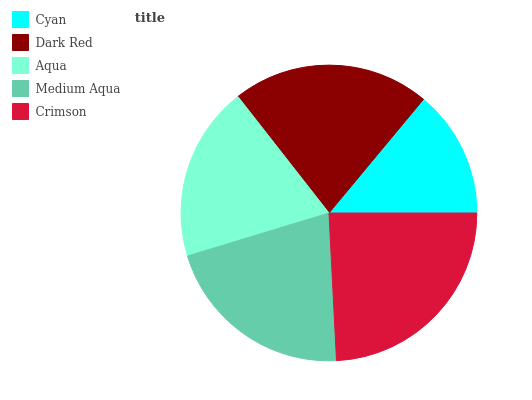Is Cyan the minimum?
Answer yes or no. Yes. Is Crimson the maximum?
Answer yes or no. Yes. Is Dark Red the minimum?
Answer yes or no. No. Is Dark Red the maximum?
Answer yes or no. No. Is Dark Red greater than Cyan?
Answer yes or no. Yes. Is Cyan less than Dark Red?
Answer yes or no. Yes. Is Cyan greater than Dark Red?
Answer yes or no. No. Is Dark Red less than Cyan?
Answer yes or no. No. Is Medium Aqua the high median?
Answer yes or no. Yes. Is Medium Aqua the low median?
Answer yes or no. Yes. Is Dark Red the high median?
Answer yes or no. No. Is Cyan the low median?
Answer yes or no. No. 